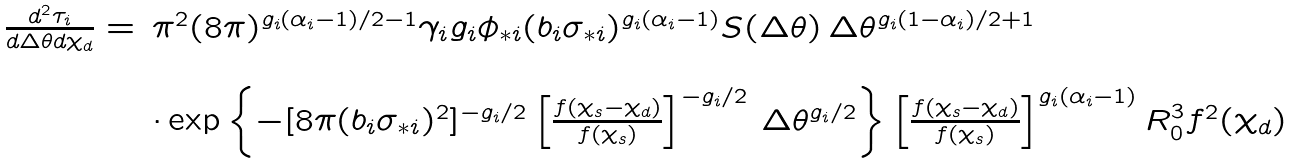<formula> <loc_0><loc_0><loc_500><loc_500>\begin{array} { l l } \frac { d ^ { 2 } \tau _ { i } } { d \Delta \theta d \chi _ { d } } = & \pi ^ { 2 } ( 8 \pi ) ^ { g _ { i } ( \alpha _ { i } - 1 ) / 2 - 1 } \gamma _ { i } g _ { i } \phi _ { * i } ( b _ { i } \sigma _ { * i } ) ^ { g _ { i } ( \alpha _ { i } - 1 ) } S ( \Delta \theta ) \, \Delta \theta ^ { g _ { i } ( 1 - \alpha _ { i } ) / 2 + 1 } \\ & \\ & \cdot \exp \left \{ - [ 8 \pi ( b _ { i } \sigma _ { * i } ) ^ { 2 } ] ^ { - g _ { i } / 2 } \left [ \frac { f ( \chi _ { s } - \chi _ { d } ) } { f ( \chi _ { s } ) } \right ] ^ { - g _ { i } / 2 } \, \Delta \theta ^ { g _ { i } / 2 } \right \} \left [ \frac { f ( \chi _ { s } - \chi _ { d } ) } { f ( \chi _ { s } ) } \right ] ^ { g _ { i } ( \alpha _ { i } - 1 ) } R _ { 0 } ^ { 3 } f ^ { 2 } ( \chi _ { d } ) \\ \end{array}</formula> 